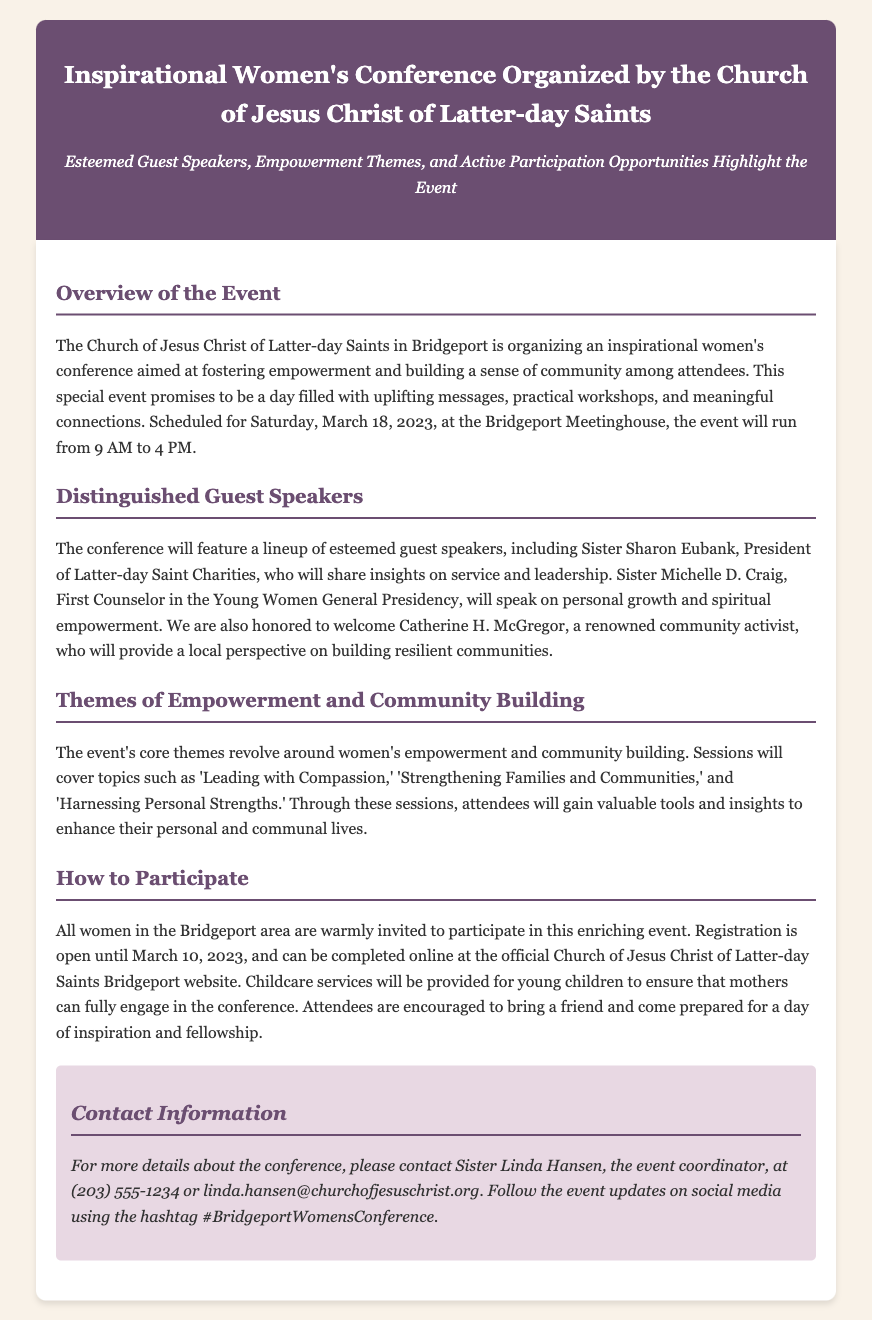What is the date of the conference? The document clearly states that the conference is scheduled for Saturday, March 18, 2023.
Answer: March 18, 2023 Who is one of the guest speakers? The document mentions several guest speakers, including Sister Sharon Eubank, President of Latter-day Saint Charities.
Answer: Sister Sharon Eubank What is the main theme of the event? The document highlights that the core themes revolve around women's empowerment and community building.
Answer: Women's empowerment and community building What time does the conference start? The document specifies that the conference will begin at 9 AM.
Answer: 9 AM Is childcare provided at the event? The document states that childcare services will be provided for young children.
Answer: Yes What is the registration deadline? According to the document, registration is open until March 10, 2023.
Answer: March 10, 2023 Who should be contacted for more details about the conference? The document provides the contact information for Sister Linda Hansen as the event coordinator.
Answer: Sister Linda Hansen What is the location of the conference? The document mentions that the event will take place at the Bridgeport Meetinghouse.
Answer: Bridgeport Meetinghouse What social media hashtag is used for the event? The document states that attendees can follow updates using the hashtag #BridgeportWomensConference.
Answer: #BridgeportWomensConference 